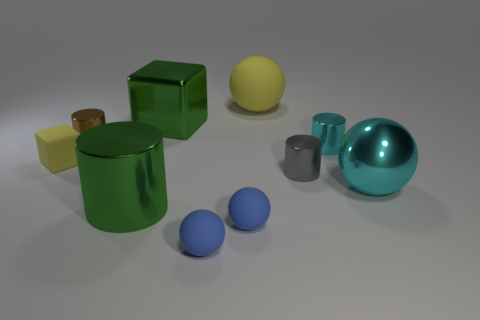What size is the object that is the same color as the small matte block?
Your response must be concise. Large. The rubber thing that is the same color as the rubber block is what shape?
Your answer should be compact. Sphere. Does the small rubber block have the same color as the big sphere that is right of the yellow sphere?
Give a very brief answer. No. How many other objects are the same material as the small gray object?
Make the answer very short. 5. Are there more cyan matte balls than matte things?
Your answer should be very brief. No. Does the small cylinder to the left of the tiny gray cylinder have the same color as the metal ball?
Ensure brevity in your answer.  No. The rubber cube is what color?
Make the answer very short. Yellow. There is a matte thing behind the yellow block; are there any yellow rubber things behind it?
Give a very brief answer. No. What is the shape of the cyan thing that is to the left of the cyan thing in front of the tiny cyan cylinder?
Your answer should be compact. Cylinder. Is the number of tiny brown shiny cylinders less than the number of green objects?
Provide a short and direct response. Yes. 